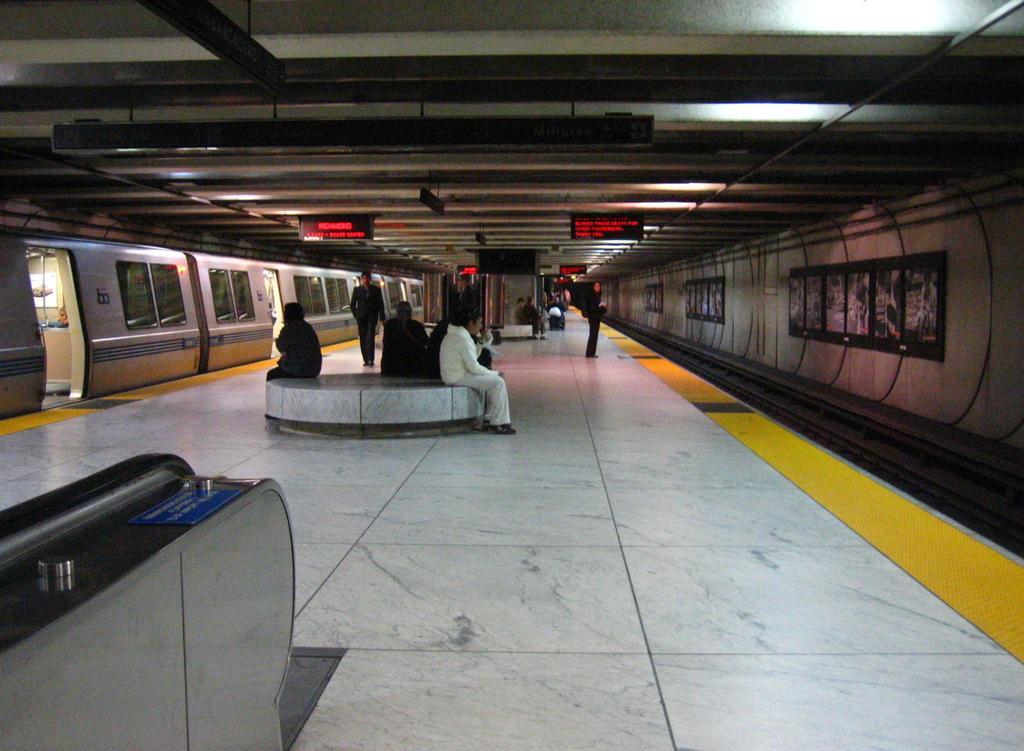Could you give a brief overview of what you see in this image? This picture describes about group of people, few are seated, few are standing and few are walking, beside to them we can see a train on the tracks, and also we can see few sign boards and lights. 